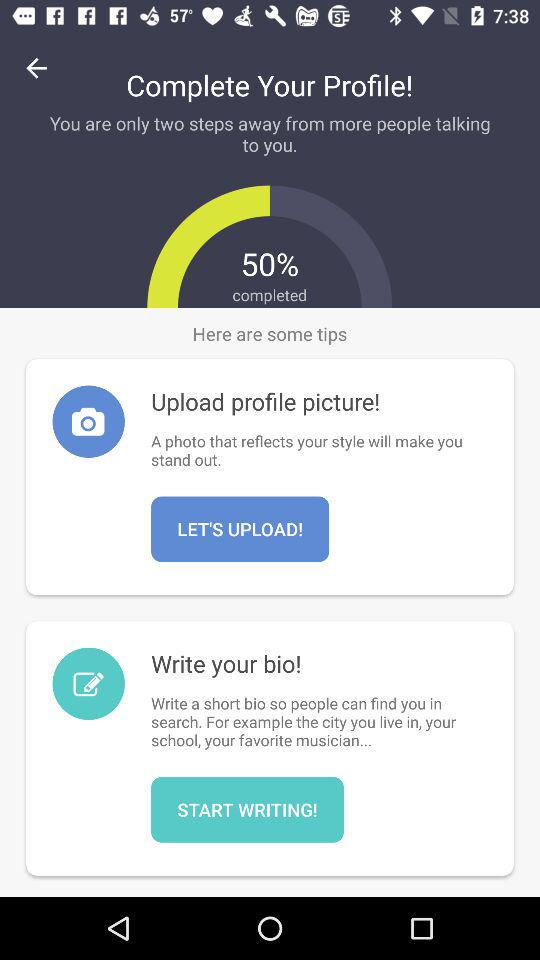How many more steps do I have to complete my profile?
Answer the question using a single word or phrase. 2 